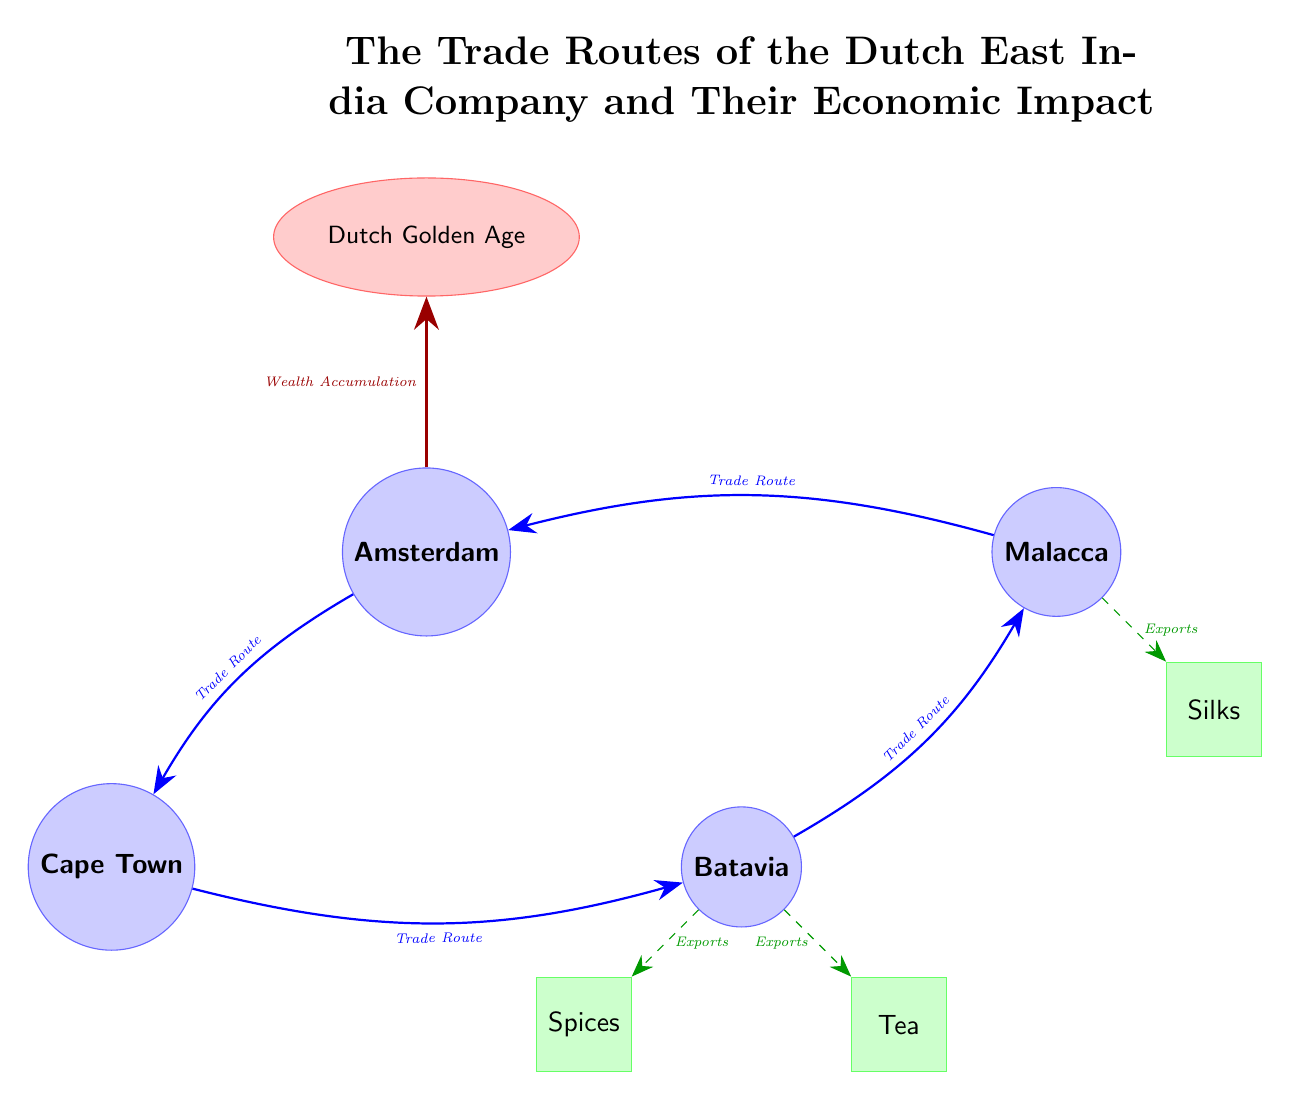What is the starting port of the trade route? The diagram shows that the trade route begins at Amsterdam, which is indicated as the first port on the left side of the diagram.
Answer: Amsterdam How many ports are illustrated in the diagram? By counting the nodes labeled as ports, we see that there are four ports depicted: Amsterdam, Cape Town, Batavia, and Malacca.
Answer: 4 What trade commodity is exported from Batavia? The diagram lists "Spices," "Silks," and "Tea" as commodities; specifically, it shows that spices are exported from Batavia, indicated by the export arrow connecting Batavia to the spices box below.
Answer: Spices What impact is associated with the trade routes of the Dutch East India Company? The diagram indicates that the trade routes lead to "Wealth Accumulation," which is the primary impact shown by the arrow connecting the route to the impact bubble at the top.
Answer: Wealth Accumulation What is the direction of the trade route from Cape Town to Batavia? The diagram describes the trade route from Cape Town to Batavia with a bend to the right, indicating a rightward direction in the flow of trade between these two ports.
Answer: Rightward Which commodity is directly associated with Malacca? The diagram shows that Malacca is linked to the export of silks, as indicated by the arrow going from Malacca to the commodities box labeled "Silks."
Answer: Silks How do the impacts of trade routes manifest in Amsterdam? The diagram illustrates this relationship with an arrow labeled "Wealth Accumulation" pointing from Amsterdam to the "Dutch Golden Age" impact node above, showing a direct link between the port and this influence.
Answer: Dutch Golden Age What is the last port before returning to Amsterdam in the trade route? Referring to the route flow, the last port before returning to Amsterdam is Malacca since the last segment of the trade route connects back to Amsterdam from Malacca directly.
Answer: Malacca 